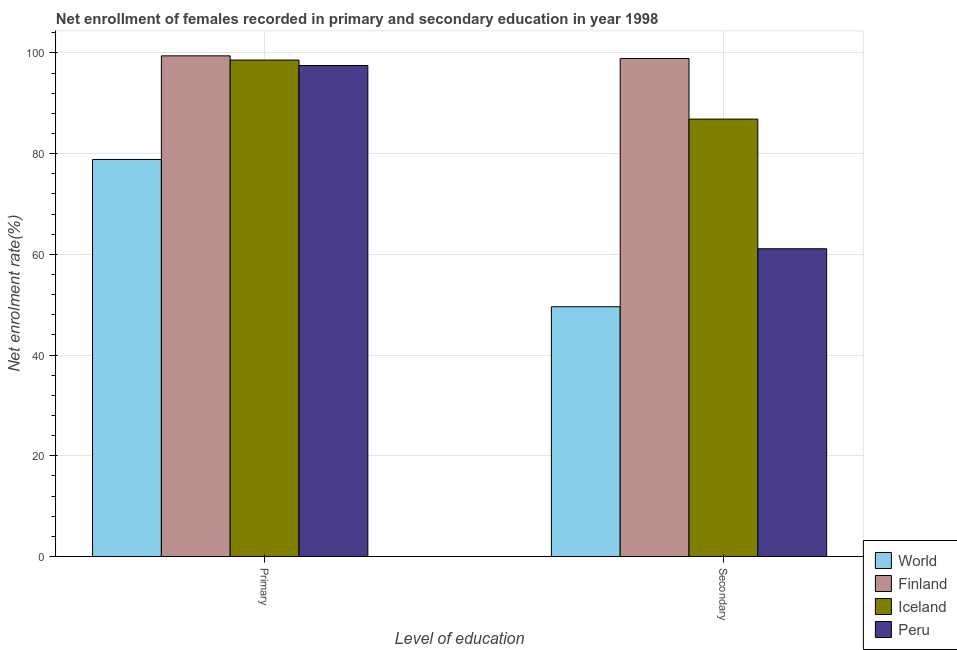How many different coloured bars are there?
Offer a terse response. 4. How many groups of bars are there?
Ensure brevity in your answer.  2. Are the number of bars per tick equal to the number of legend labels?
Give a very brief answer. Yes. Are the number of bars on each tick of the X-axis equal?
Keep it short and to the point. Yes. How many bars are there on the 1st tick from the right?
Your answer should be very brief. 4. What is the label of the 1st group of bars from the left?
Make the answer very short. Primary. What is the enrollment rate in secondary education in Finland?
Keep it short and to the point. 98.88. Across all countries, what is the maximum enrollment rate in secondary education?
Your response must be concise. 98.88. Across all countries, what is the minimum enrollment rate in primary education?
Provide a short and direct response. 78.83. What is the total enrollment rate in secondary education in the graph?
Your answer should be very brief. 296.42. What is the difference between the enrollment rate in secondary education in Peru and that in Iceland?
Ensure brevity in your answer.  -25.74. What is the difference between the enrollment rate in primary education in Finland and the enrollment rate in secondary education in Peru?
Provide a succinct answer. 38.3. What is the average enrollment rate in secondary education per country?
Offer a terse response. 74.11. What is the difference between the enrollment rate in secondary education and enrollment rate in primary education in Peru?
Provide a short and direct response. -36.38. In how many countries, is the enrollment rate in secondary education greater than 4 %?
Your answer should be compact. 4. What is the ratio of the enrollment rate in secondary education in Finland to that in Iceland?
Your answer should be compact. 1.14. What does the 2nd bar from the right in Primary represents?
Keep it short and to the point. Iceland. How many bars are there?
Your answer should be compact. 8. Are all the bars in the graph horizontal?
Provide a short and direct response. No. How many countries are there in the graph?
Give a very brief answer. 4. What is the difference between two consecutive major ticks on the Y-axis?
Your answer should be very brief. 20. Does the graph contain any zero values?
Your answer should be very brief. No. Does the graph contain grids?
Offer a terse response. Yes. Where does the legend appear in the graph?
Your answer should be compact. Bottom right. How many legend labels are there?
Your answer should be very brief. 4. What is the title of the graph?
Give a very brief answer. Net enrollment of females recorded in primary and secondary education in year 1998. Does "Maldives" appear as one of the legend labels in the graph?
Give a very brief answer. No. What is the label or title of the X-axis?
Your answer should be compact. Level of education. What is the label or title of the Y-axis?
Your answer should be very brief. Net enrolment rate(%). What is the Net enrolment rate(%) of World in Primary?
Provide a short and direct response. 78.83. What is the Net enrolment rate(%) of Finland in Primary?
Provide a short and direct response. 99.4. What is the Net enrolment rate(%) in Iceland in Primary?
Your answer should be very brief. 98.57. What is the Net enrolment rate(%) of Peru in Primary?
Ensure brevity in your answer.  97.48. What is the Net enrolment rate(%) in World in Secondary?
Ensure brevity in your answer.  49.59. What is the Net enrolment rate(%) in Finland in Secondary?
Make the answer very short. 98.88. What is the Net enrolment rate(%) in Iceland in Secondary?
Your answer should be very brief. 86.85. What is the Net enrolment rate(%) of Peru in Secondary?
Ensure brevity in your answer.  61.1. Across all Level of education, what is the maximum Net enrolment rate(%) in World?
Your answer should be compact. 78.83. Across all Level of education, what is the maximum Net enrolment rate(%) of Finland?
Offer a very short reply. 99.4. Across all Level of education, what is the maximum Net enrolment rate(%) of Iceland?
Keep it short and to the point. 98.57. Across all Level of education, what is the maximum Net enrolment rate(%) in Peru?
Offer a very short reply. 97.48. Across all Level of education, what is the minimum Net enrolment rate(%) of World?
Provide a succinct answer. 49.59. Across all Level of education, what is the minimum Net enrolment rate(%) in Finland?
Keep it short and to the point. 98.88. Across all Level of education, what is the minimum Net enrolment rate(%) in Iceland?
Your answer should be compact. 86.85. Across all Level of education, what is the minimum Net enrolment rate(%) of Peru?
Provide a short and direct response. 61.1. What is the total Net enrolment rate(%) of World in the graph?
Keep it short and to the point. 128.42. What is the total Net enrolment rate(%) in Finland in the graph?
Offer a terse response. 198.29. What is the total Net enrolment rate(%) of Iceland in the graph?
Make the answer very short. 185.42. What is the total Net enrolment rate(%) of Peru in the graph?
Give a very brief answer. 158.59. What is the difference between the Net enrolment rate(%) in World in Primary and that in Secondary?
Make the answer very short. 29.24. What is the difference between the Net enrolment rate(%) in Finland in Primary and that in Secondary?
Your response must be concise. 0.52. What is the difference between the Net enrolment rate(%) in Iceland in Primary and that in Secondary?
Provide a short and direct response. 11.72. What is the difference between the Net enrolment rate(%) in Peru in Primary and that in Secondary?
Give a very brief answer. 36.38. What is the difference between the Net enrolment rate(%) in World in Primary and the Net enrolment rate(%) in Finland in Secondary?
Give a very brief answer. -20.05. What is the difference between the Net enrolment rate(%) in World in Primary and the Net enrolment rate(%) in Iceland in Secondary?
Make the answer very short. -8.02. What is the difference between the Net enrolment rate(%) of World in Primary and the Net enrolment rate(%) of Peru in Secondary?
Make the answer very short. 17.73. What is the difference between the Net enrolment rate(%) of Finland in Primary and the Net enrolment rate(%) of Iceland in Secondary?
Offer a very short reply. 12.56. What is the difference between the Net enrolment rate(%) of Finland in Primary and the Net enrolment rate(%) of Peru in Secondary?
Your answer should be compact. 38.3. What is the difference between the Net enrolment rate(%) of Iceland in Primary and the Net enrolment rate(%) of Peru in Secondary?
Ensure brevity in your answer.  37.46. What is the average Net enrolment rate(%) of World per Level of education?
Provide a succinct answer. 64.21. What is the average Net enrolment rate(%) of Finland per Level of education?
Your answer should be very brief. 99.14. What is the average Net enrolment rate(%) in Iceland per Level of education?
Ensure brevity in your answer.  92.71. What is the average Net enrolment rate(%) in Peru per Level of education?
Offer a terse response. 79.29. What is the difference between the Net enrolment rate(%) in World and Net enrolment rate(%) in Finland in Primary?
Your response must be concise. -20.57. What is the difference between the Net enrolment rate(%) in World and Net enrolment rate(%) in Iceland in Primary?
Keep it short and to the point. -19.74. What is the difference between the Net enrolment rate(%) in World and Net enrolment rate(%) in Peru in Primary?
Provide a short and direct response. -18.65. What is the difference between the Net enrolment rate(%) in Finland and Net enrolment rate(%) in Iceland in Primary?
Provide a short and direct response. 0.84. What is the difference between the Net enrolment rate(%) in Finland and Net enrolment rate(%) in Peru in Primary?
Your response must be concise. 1.92. What is the difference between the Net enrolment rate(%) in Iceland and Net enrolment rate(%) in Peru in Primary?
Keep it short and to the point. 1.08. What is the difference between the Net enrolment rate(%) of World and Net enrolment rate(%) of Finland in Secondary?
Provide a succinct answer. -49.29. What is the difference between the Net enrolment rate(%) in World and Net enrolment rate(%) in Iceland in Secondary?
Give a very brief answer. -37.26. What is the difference between the Net enrolment rate(%) in World and Net enrolment rate(%) in Peru in Secondary?
Make the answer very short. -11.51. What is the difference between the Net enrolment rate(%) of Finland and Net enrolment rate(%) of Iceland in Secondary?
Ensure brevity in your answer.  12.03. What is the difference between the Net enrolment rate(%) of Finland and Net enrolment rate(%) of Peru in Secondary?
Give a very brief answer. 37.78. What is the difference between the Net enrolment rate(%) of Iceland and Net enrolment rate(%) of Peru in Secondary?
Make the answer very short. 25.74. What is the ratio of the Net enrolment rate(%) in World in Primary to that in Secondary?
Make the answer very short. 1.59. What is the ratio of the Net enrolment rate(%) in Finland in Primary to that in Secondary?
Ensure brevity in your answer.  1.01. What is the ratio of the Net enrolment rate(%) in Iceland in Primary to that in Secondary?
Provide a short and direct response. 1.14. What is the ratio of the Net enrolment rate(%) of Peru in Primary to that in Secondary?
Give a very brief answer. 1.6. What is the difference between the highest and the second highest Net enrolment rate(%) in World?
Your answer should be very brief. 29.24. What is the difference between the highest and the second highest Net enrolment rate(%) of Finland?
Keep it short and to the point. 0.52. What is the difference between the highest and the second highest Net enrolment rate(%) in Iceland?
Offer a terse response. 11.72. What is the difference between the highest and the second highest Net enrolment rate(%) of Peru?
Give a very brief answer. 36.38. What is the difference between the highest and the lowest Net enrolment rate(%) of World?
Your answer should be compact. 29.24. What is the difference between the highest and the lowest Net enrolment rate(%) of Finland?
Provide a succinct answer. 0.52. What is the difference between the highest and the lowest Net enrolment rate(%) of Iceland?
Your answer should be compact. 11.72. What is the difference between the highest and the lowest Net enrolment rate(%) in Peru?
Give a very brief answer. 36.38. 